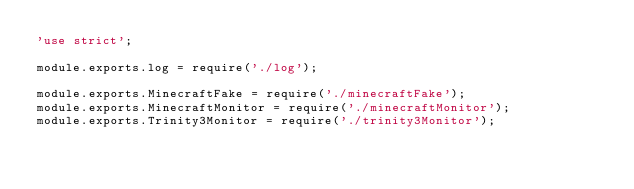Convert code to text. <code><loc_0><loc_0><loc_500><loc_500><_JavaScript_>'use strict';

module.exports.log = require('./log');

module.exports.MinecraftFake = require('./minecraftFake');
module.exports.MinecraftMonitor = require('./minecraftMonitor');
module.exports.Trinity3Monitor = require('./trinity3Monitor');
</code> 